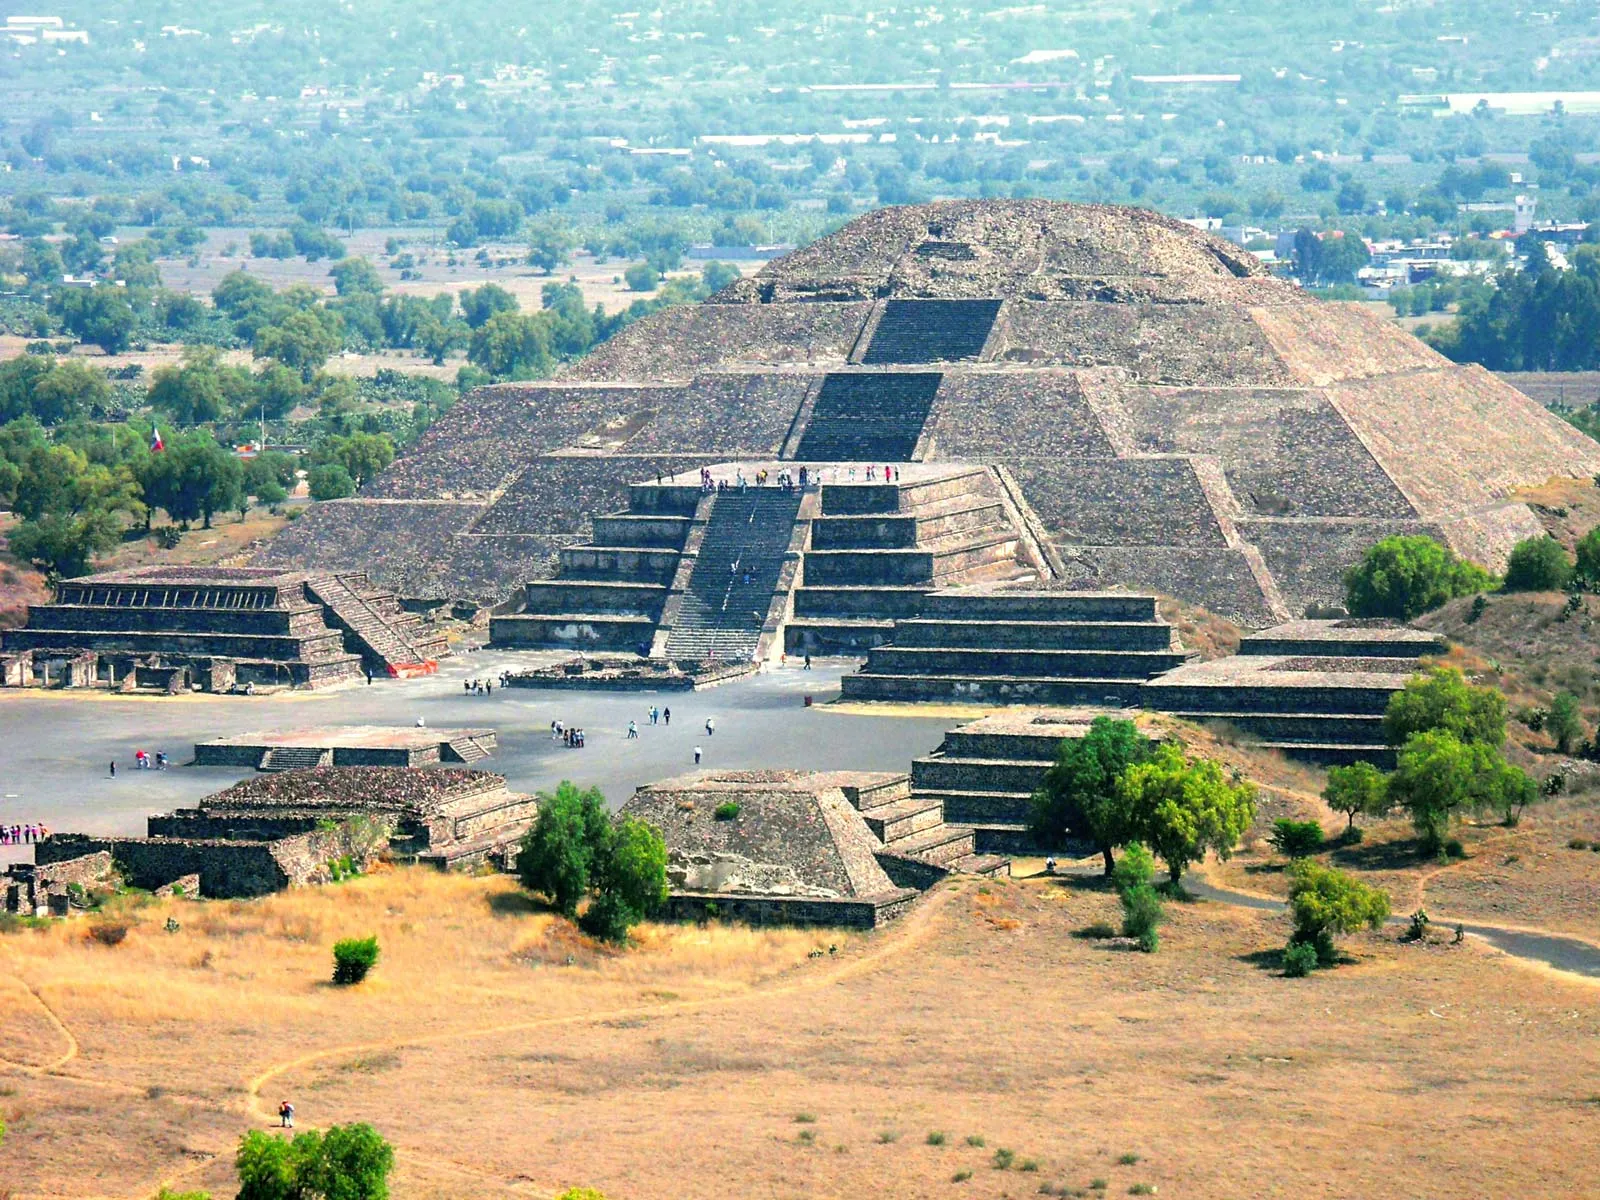Describe a present-day tourist visiting this pyramid and what they might experience. A present-day tourist visiting the Pyramid of the Sun would embark on a journey through time, marveling at the immense stone structure that has stood for centuries. As they approach, they would feel a sense of awe at its sheer size and the intricacy of its construction. Climbing the pyramid's steps, the tourist would pause to take in the panoramic views of the surrounding archaeological site and the verdant landscape. At the summit, they might reflect on the ancient ceremonies that once took place there, feeling a connection to the past. The visit could be enriched by a guided tour, where experts share fascinating insights into the history and significance of Teotihuacan. The day might end with the tourist exploring nearby museums, encountering artifacts that bring the ancient city to life, before experiencing the local culture, cuisine, and hospitality of Mexico. 